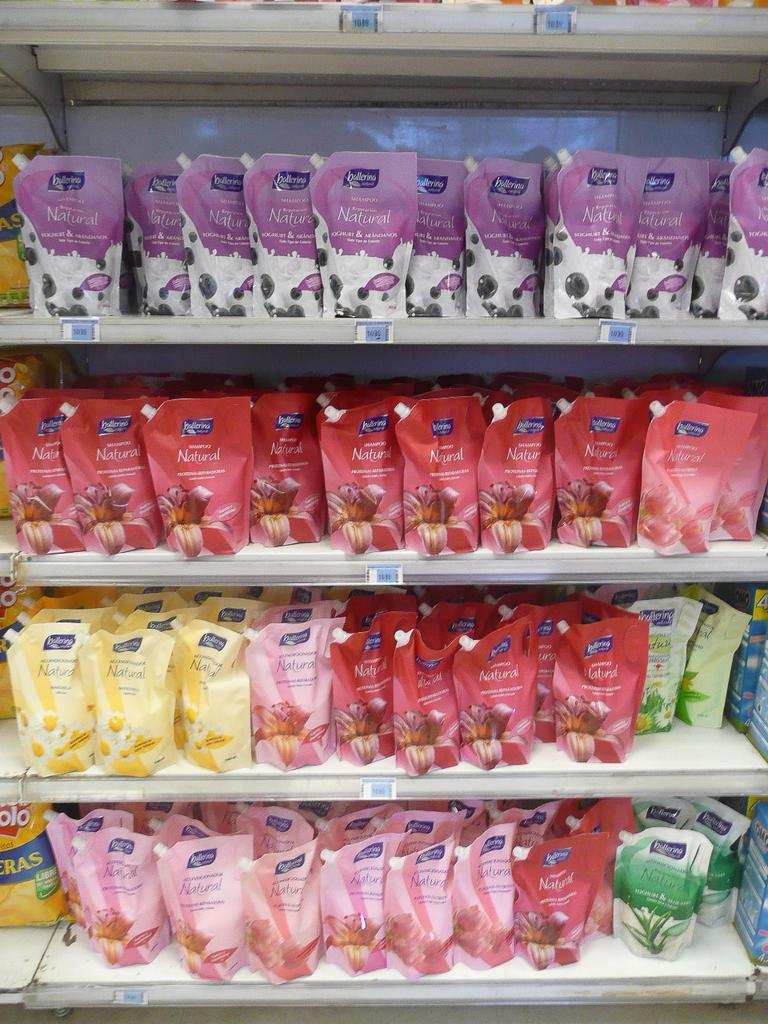<image>
Share a concise interpretation of the image provided. a group of candies with have ballerina written on them 